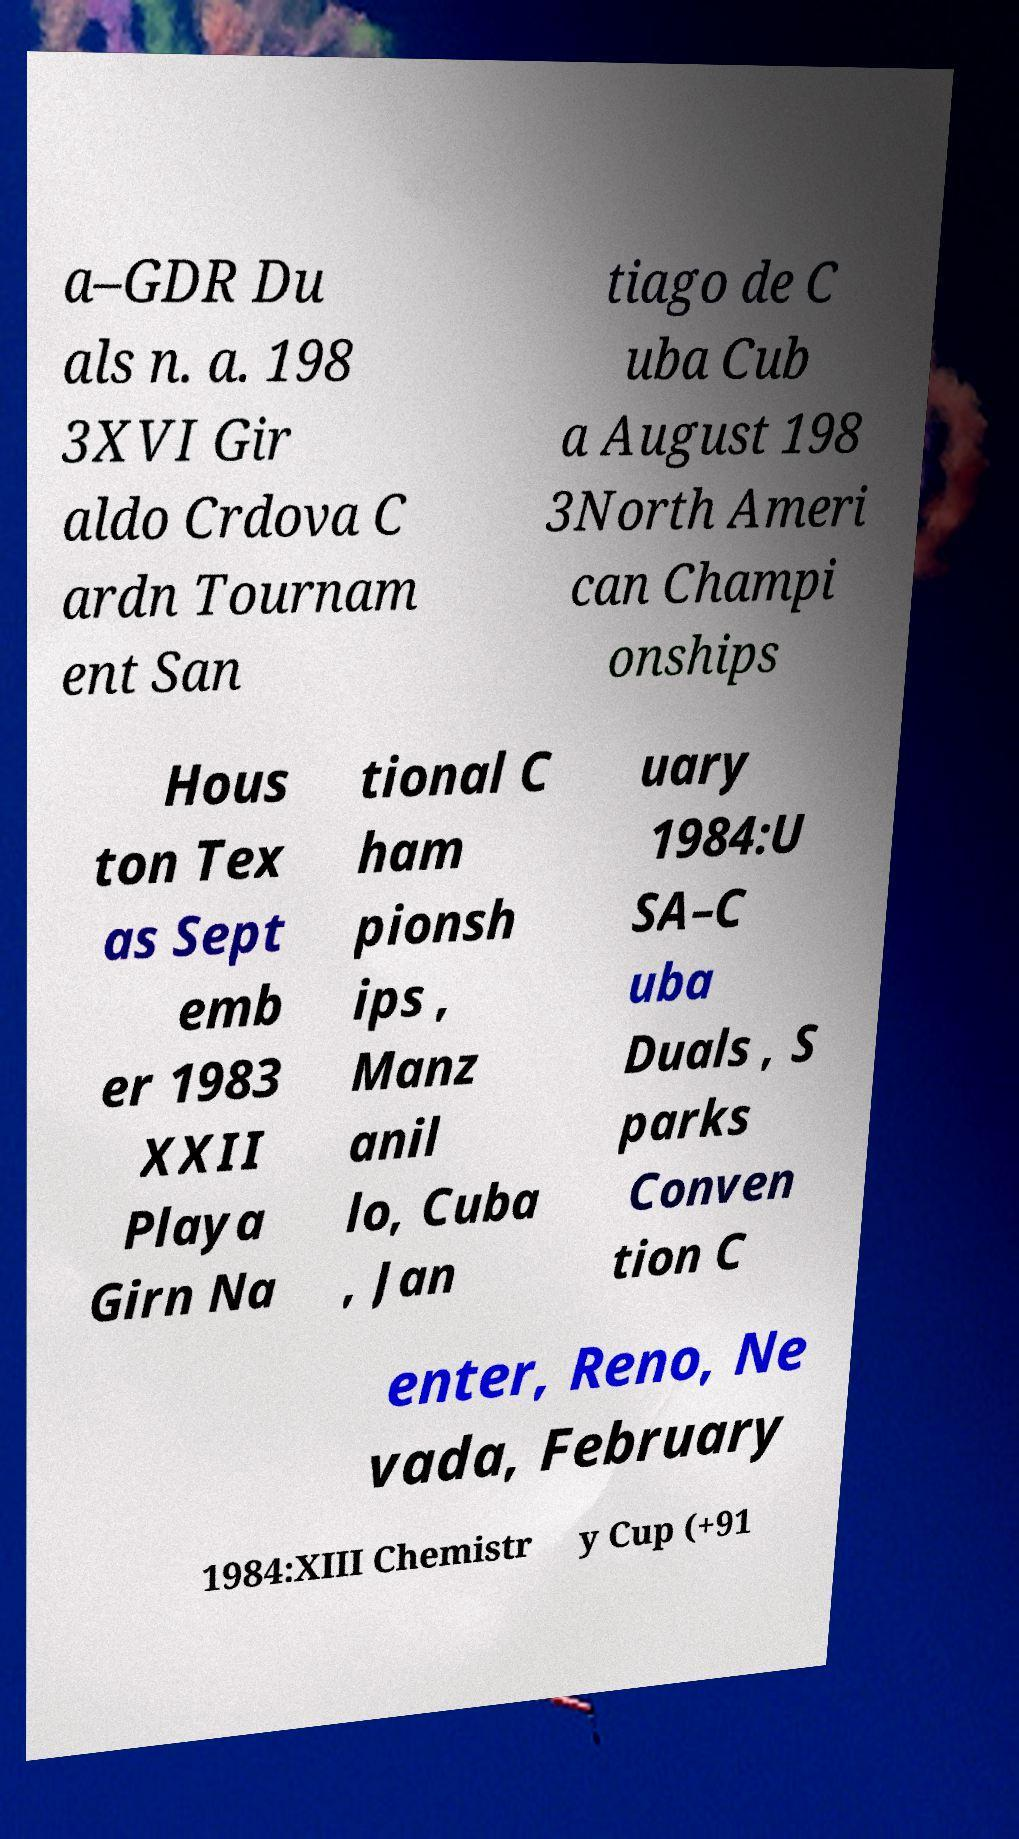Can you read and provide the text displayed in the image?This photo seems to have some interesting text. Can you extract and type it out for me? a–GDR Du als n. a. 198 3XVI Gir aldo Crdova C ardn Tournam ent San tiago de C uba Cub a August 198 3North Ameri can Champi onships Hous ton Tex as Sept emb er 1983 XXII Playa Girn Na tional C ham pionsh ips , Manz anil lo, Cuba , Jan uary 1984:U SA–C uba Duals , S parks Conven tion C enter, Reno, Ne vada, February 1984:XIII Chemistr y Cup (+91 